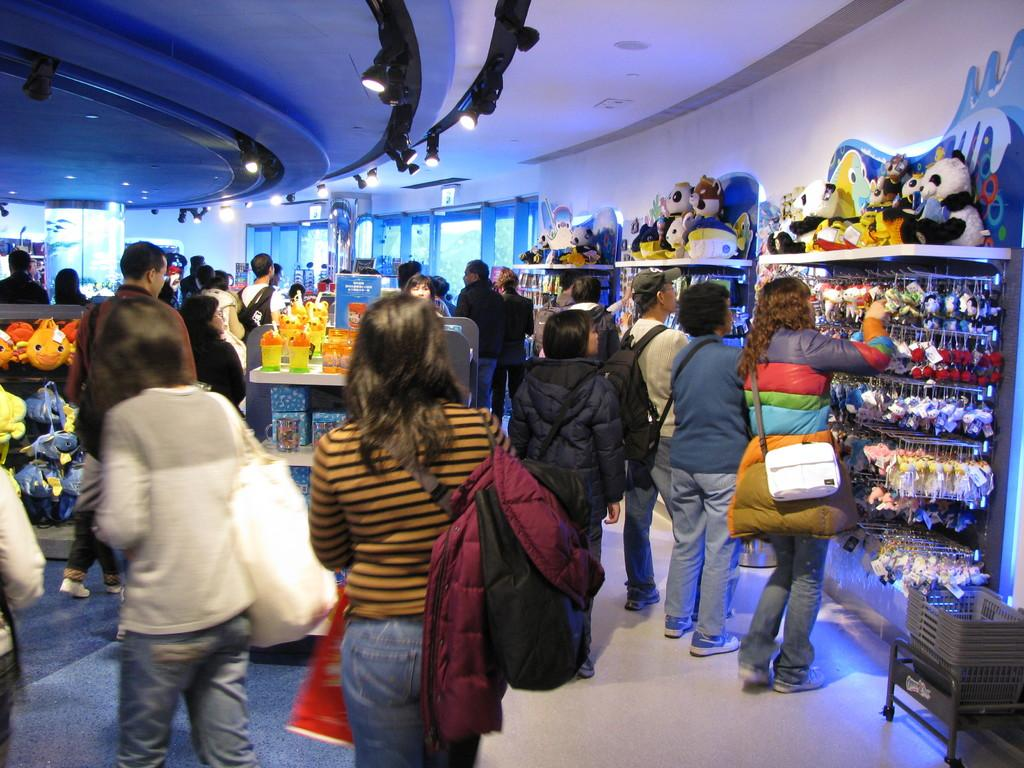What are the people in the image doing? There is a group of people standing on the floor in the image. What type of clothing can be seen in the image? There are jackets visible in the image. What type of items are present in the image that might be used for play? There are toys in the image. What type of containers are present in the image? There are baskets in the image. What type of illumination is present in the image? There are lights in the image. What type of architectural feature is present in the image? There is a wall in the image. What type of objects are present in the image? There are some objects in the image. What type of openings can be seen in the background of the image? There are windows visible in the background. What type of snails can be seen crawling on the wall in the image? There are no snails visible in the image; only people, jackets, toys, baskets, lights, objects, and windows are present. What type of prose is being recited by the people in the image? There is no indication in the image that the people are reciting any prose. 